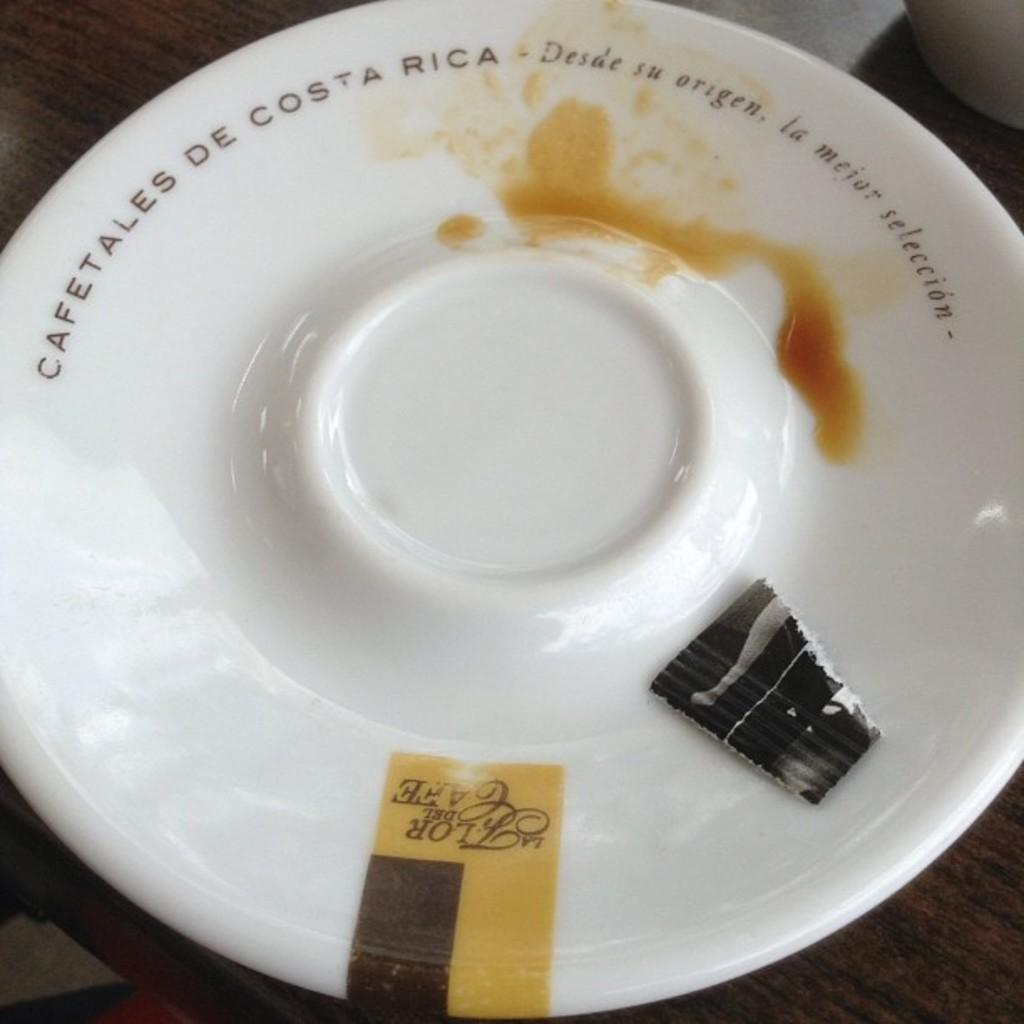What is on the wooden surface in the image? There is a plate on the wooden surface in the image. Can you describe the plate in the image? The plate is on a wooden surface. What else can be seen in the image besides the plate? There are objects present in the image. How many fingers can be seen touching the plate in the image? There are no fingers touching the plate in the image. What type of milk is being poured onto the plate in the image? There is no milk present in the image. 